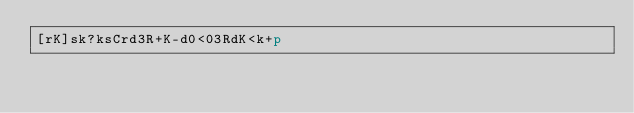Convert code to text. <code><loc_0><loc_0><loc_500><loc_500><_dc_>[rK]sk?ksCrd3R+K-d0<03RdK<k+p</code> 